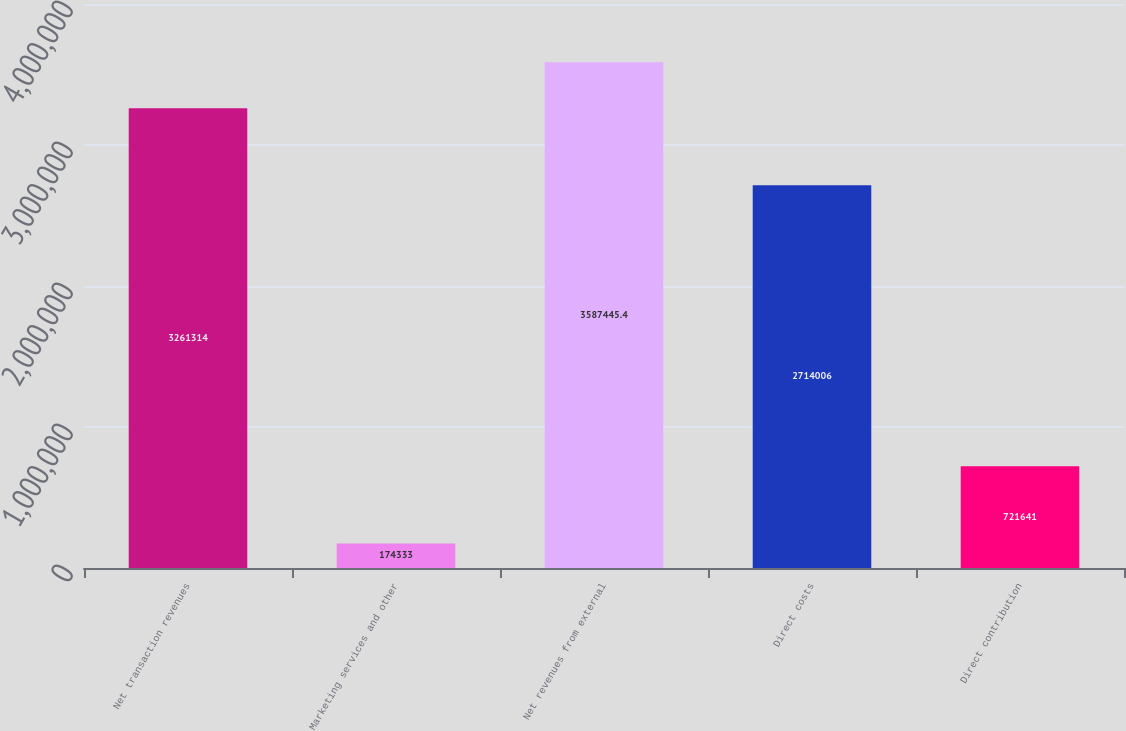Convert chart to OTSL. <chart><loc_0><loc_0><loc_500><loc_500><bar_chart><fcel>Net transaction revenues<fcel>Marketing services and other<fcel>Net revenues from external<fcel>Direct costs<fcel>Direct contribution<nl><fcel>3.26131e+06<fcel>174333<fcel>3.58745e+06<fcel>2.71401e+06<fcel>721641<nl></chart> 